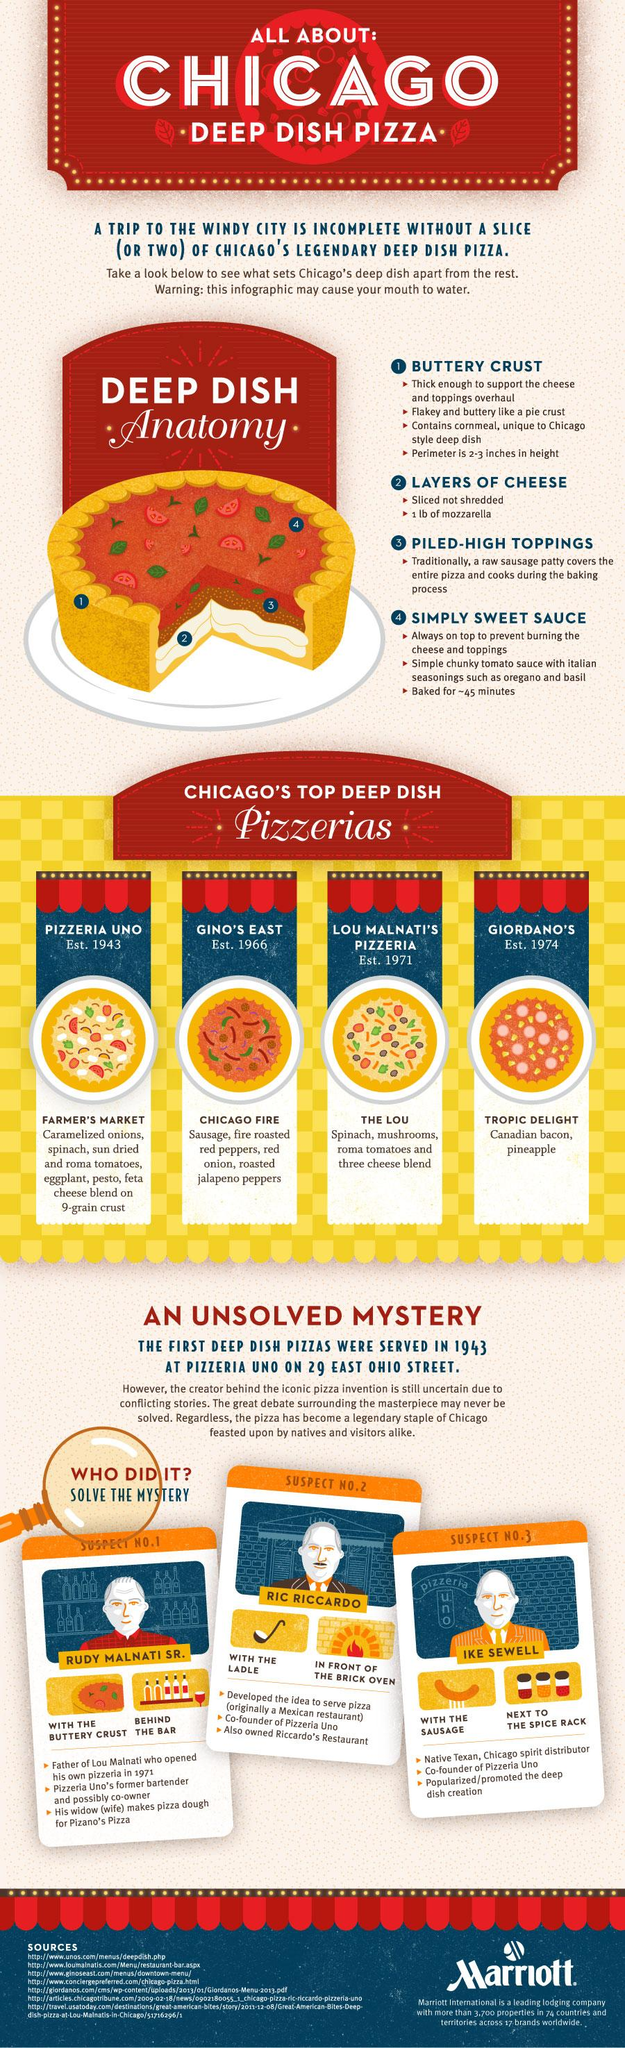Identify some key points in this picture. The Pizzeria Uno is the oldest pizzeria listed in the infographic, according to the provided information. The pizza's perimeter has a thickness of approximately 2-3 inches. 